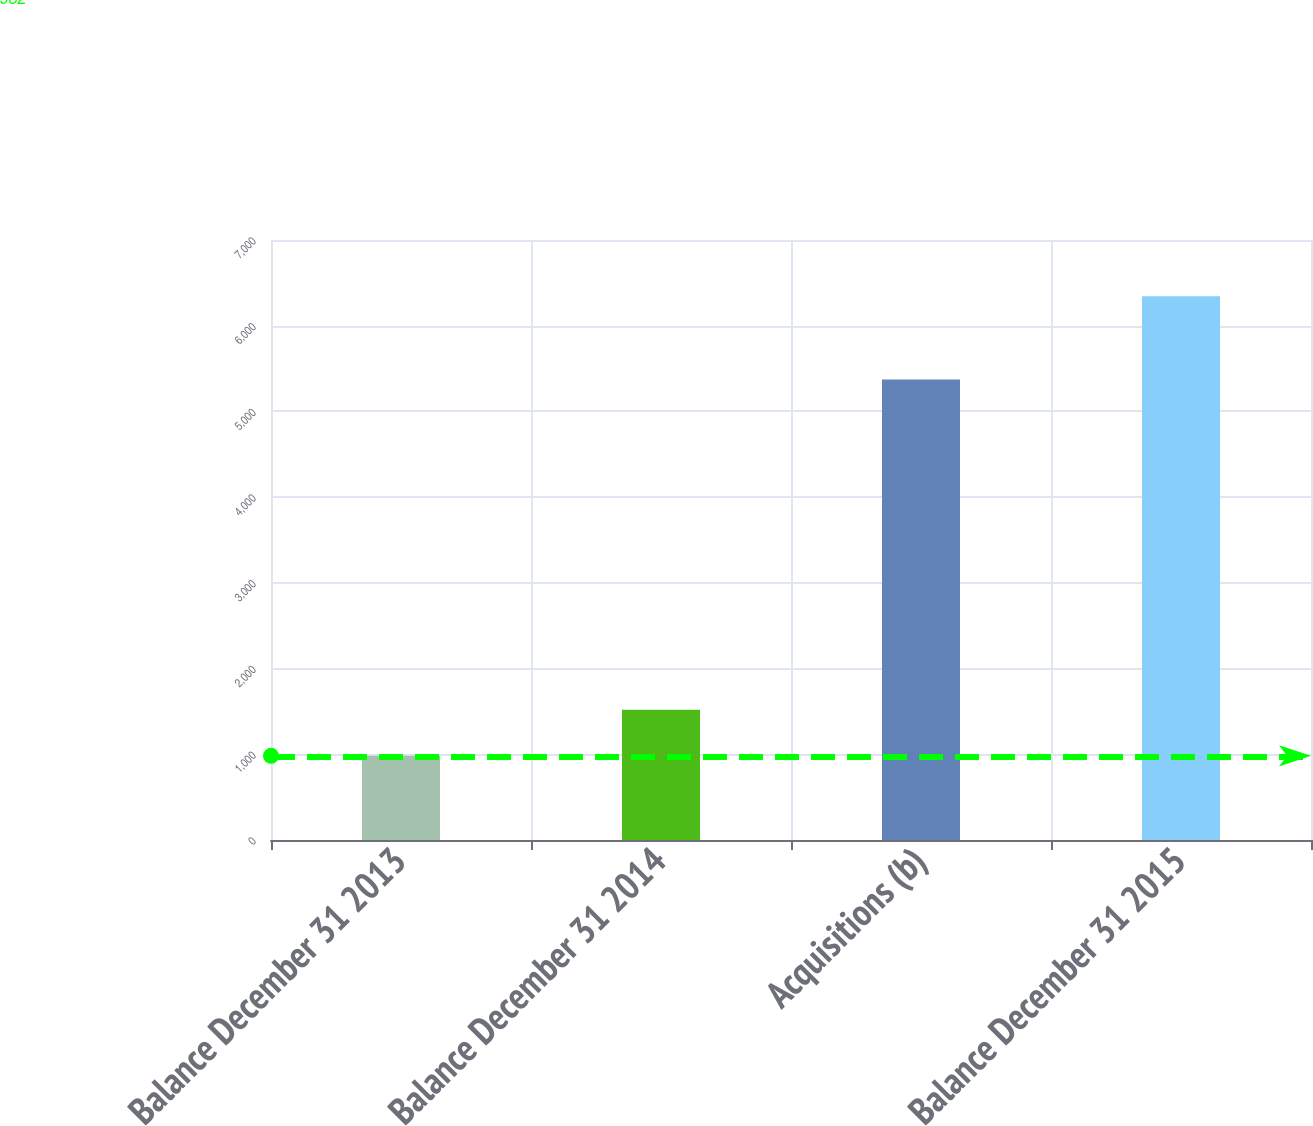<chart> <loc_0><loc_0><loc_500><loc_500><bar_chart><fcel>Balance December 31 2013<fcel>Balance December 31 2014<fcel>Acquisitions (b)<fcel>Balance December 31 2015<nl><fcel>982<fcel>1518.2<fcel>5373<fcel>6344<nl></chart> 